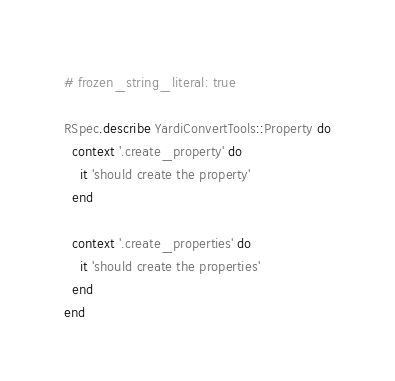Convert code to text. <code><loc_0><loc_0><loc_500><loc_500><_Ruby_># frozen_string_literal: true

RSpec.describe YardiConvertTools::Property do
  context '.create_property' do
    it 'should create the property'
  end

  context '.create_properties' do
    it 'should create the properties'
  end
end
</code> 